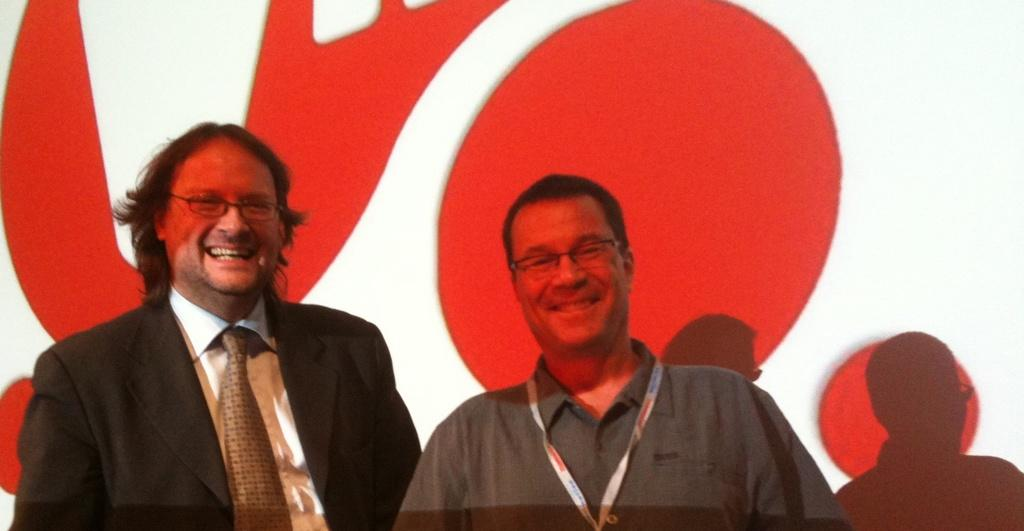How many people are in the image? There are two persons in the image. What are the two persons doing in the image? The two persons are standing. What expressions do the two persons have in the image? The two persons are smiling. What can be seen in the background of the image? There is a wall in the background of the image. What type of swing can be seen in the image? There is no swing present in the image. What kind of structure is visible in the background of the image? The background of the image only shows a wall, and no other structures are visible. 